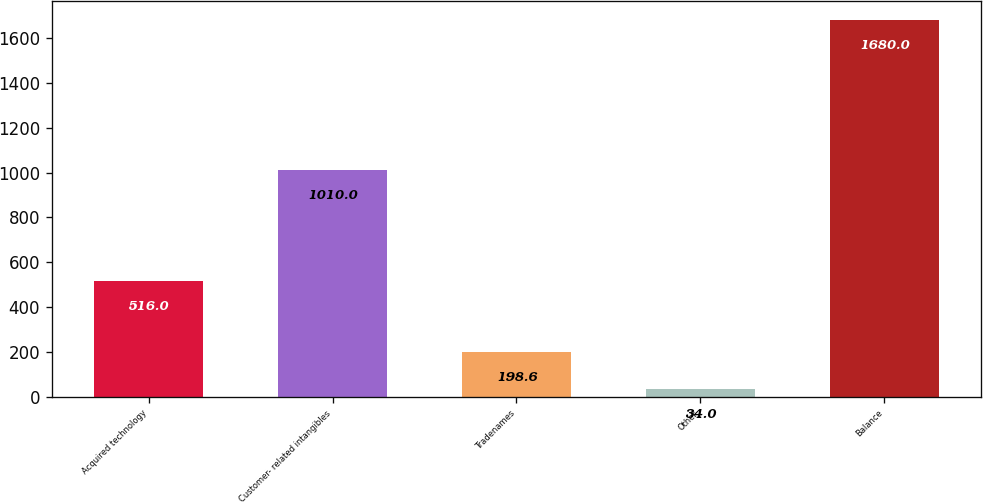<chart> <loc_0><loc_0><loc_500><loc_500><bar_chart><fcel>Acquired technology<fcel>Customer- related intangibles<fcel>Tradenames<fcel>Other<fcel>Balance<nl><fcel>516<fcel>1010<fcel>198.6<fcel>34<fcel>1680<nl></chart> 